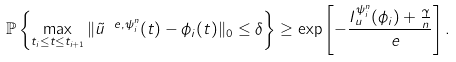Convert formula to latex. <formula><loc_0><loc_0><loc_500><loc_500>\mathbb { P } \left \{ \max _ { t _ { i } \leq t \leq t _ { i + 1 } } \| \tilde { u } ^ { \ e , \psi _ { i } ^ { n } } ( t ) - \phi _ { i } ( t ) \| _ { 0 } \leq \delta \right \} \geq \exp \left [ - \frac { I _ { u } ^ { \psi _ { i } ^ { n } } ( \phi _ { i } ) + \frac { \gamma } { n } } { \ e } \right ] .</formula> 